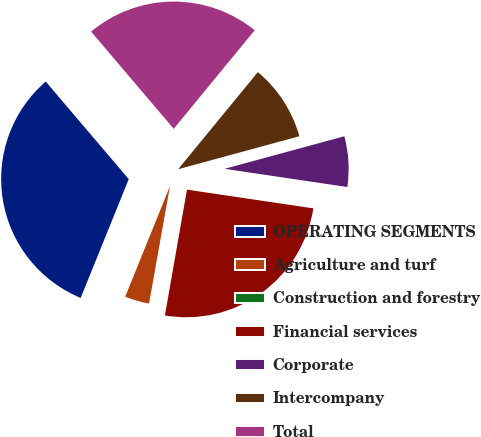<chart> <loc_0><loc_0><loc_500><loc_500><pie_chart><fcel>OPERATING SEGMENTS<fcel>Agriculture and turf<fcel>Construction and forestry<fcel>Financial services<fcel>Corporate<fcel>Intercompany<fcel>Total<nl><fcel>32.66%<fcel>3.31%<fcel>0.05%<fcel>25.42%<fcel>6.57%<fcel>9.83%<fcel>22.16%<nl></chart> 